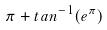Convert formula to latex. <formula><loc_0><loc_0><loc_500><loc_500>\pi + t a n ^ { - 1 } ( e ^ { \pi } )</formula> 